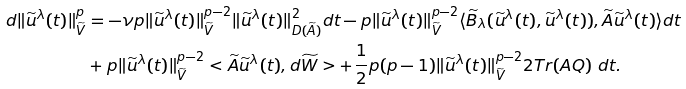Convert formula to latex. <formula><loc_0><loc_0><loc_500><loc_500>d \| \widetilde { u } ^ { \lambda } ( t ) \| ^ { p } _ { \widetilde { V } } & = - \nu p \| \widetilde { u } ^ { \lambda } ( t ) \| ^ { p - 2 } _ { \widetilde { V } } \| \widetilde { u } ^ { \lambda } ( t ) \| ^ { 2 } _ { D ( \widetilde { A } ) } d t - p \| \widetilde { u } ^ { \lambda } ( t ) \| ^ { p - 2 } _ { \widetilde { V } } \langle \widetilde { B } _ { \lambda } ( \widetilde { u } ^ { \lambda } ( t ) , \widetilde { u } ^ { \lambda } ( t ) ) , \widetilde { A } \widetilde { u } ^ { \lambda } ( t ) \rangle d t \\ & + p \| \widetilde { u } ^ { \lambda } ( t ) \| ^ { p - 2 } _ { \widetilde { V } } < \widetilde { A } \widetilde { u } ^ { \lambda } ( t ) , d \widetilde { W } > + \frac { 1 } { 2 } p ( p - 1 ) \| \widetilde { u } ^ { \lambda } ( t ) \| ^ { p - 2 } _ { \widetilde { V } } 2 T r ( A Q ) \ d t .</formula> 